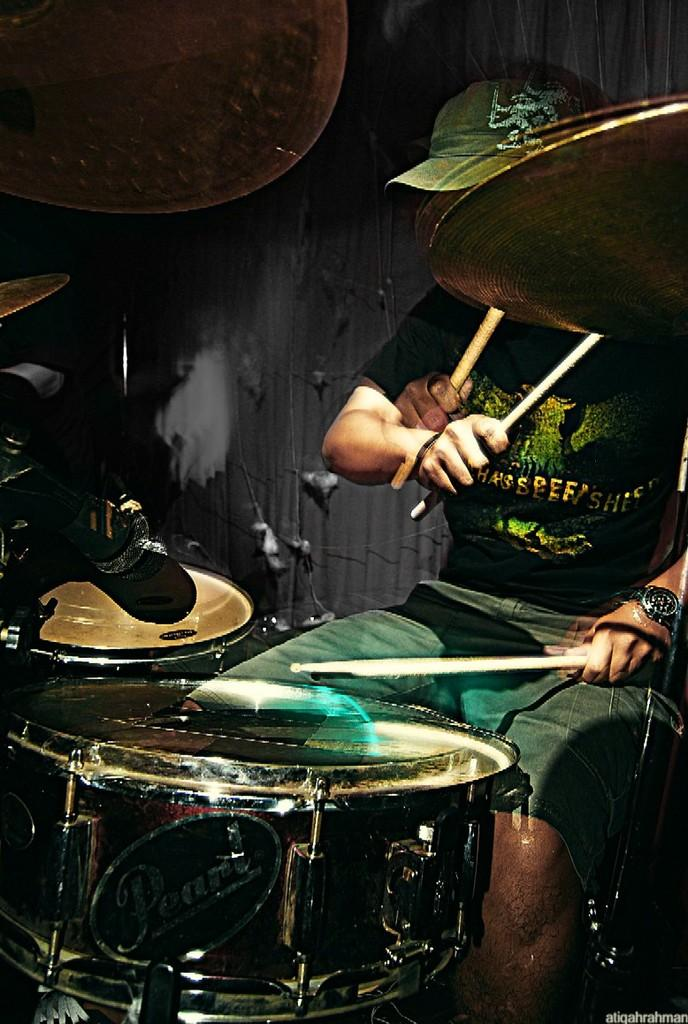Who is the main subject in the foreground of the image? There is a man in the foreground of the image. What is the man wearing on his head? The man is wearing a cap. What is the man doing in the image? The man is sitting and playing drums. Can you describe the background of the image? The background of the image is not clear. How many eggs can be seen in the man's muscles in the image? There are no eggs visible in the man's muscles in the image. What type of cabbage is being used as a drumstick in the image? There is no cabbage being used as a drumstick in the image; the man is using drumsticks or his hands to play the drums. 